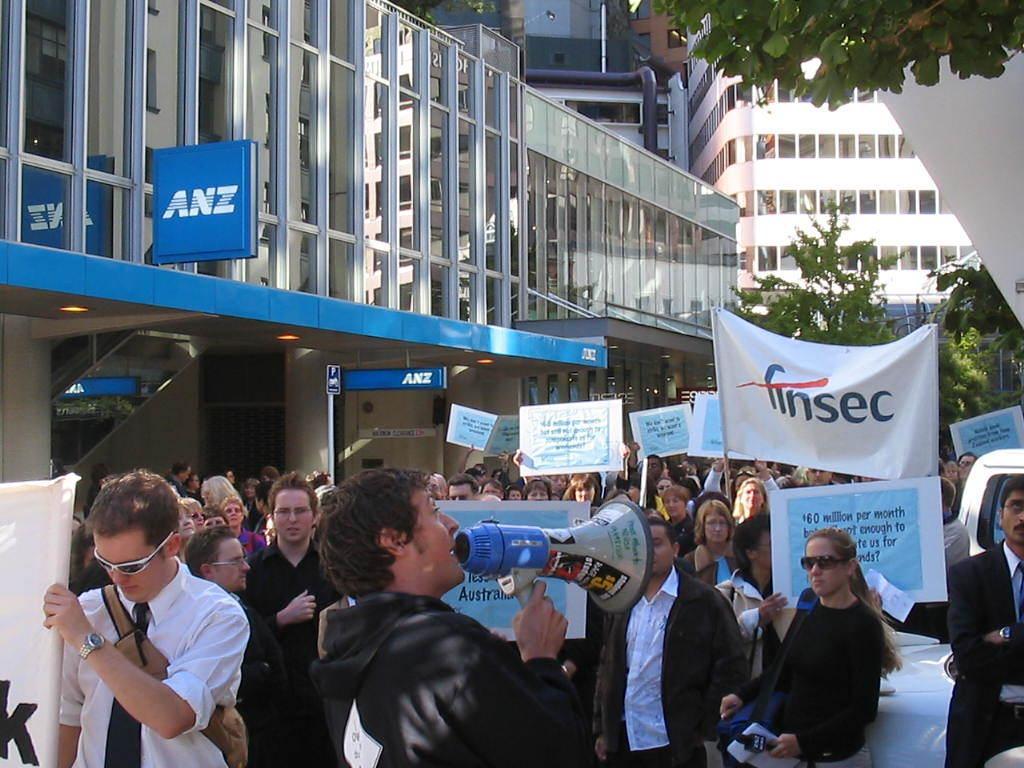Can you describe this image briefly? In this picture we can see people holding banners and protesting. Here we can see a man holding a loudspeaker. Here we can see a man wearing white shirt, goggles and a wrist watch. In the background we can see buildings and trees. 